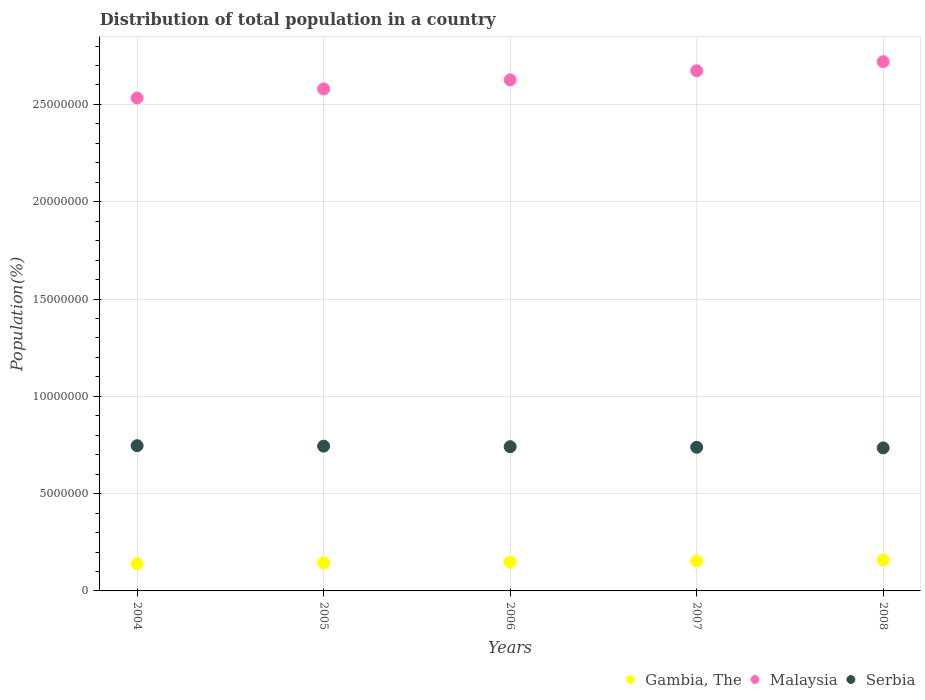Is the number of dotlines equal to the number of legend labels?
Ensure brevity in your answer.  Yes. What is the population of in Gambia, The in 2004?
Your answer should be compact. 1.39e+06. Across all years, what is the maximum population of in Malaysia?
Give a very brief answer. 2.72e+07. Across all years, what is the minimum population of in Malaysia?
Make the answer very short. 2.53e+07. In which year was the population of in Gambia, The maximum?
Your response must be concise. 2008. What is the total population of in Serbia in the graph?
Your response must be concise. 3.70e+07. What is the difference between the population of in Serbia in 2005 and that in 2008?
Offer a very short reply. 9.05e+04. What is the difference between the population of in Malaysia in 2006 and the population of in Serbia in 2007?
Make the answer very short. 1.89e+07. What is the average population of in Malaysia per year?
Keep it short and to the point. 2.63e+07. In the year 2008, what is the difference between the population of in Malaysia and population of in Serbia?
Provide a succinct answer. 1.98e+07. In how many years, is the population of in Malaysia greater than 13000000 %?
Make the answer very short. 5. What is the ratio of the population of in Malaysia in 2005 to that in 2008?
Your answer should be compact. 0.95. Is the population of in Serbia in 2005 less than that in 2006?
Keep it short and to the point. No. Is the difference between the population of in Malaysia in 2005 and 2008 greater than the difference between the population of in Serbia in 2005 and 2008?
Your response must be concise. No. What is the difference between the highest and the second highest population of in Malaysia?
Give a very brief answer. 4.67e+05. What is the difference between the highest and the lowest population of in Malaysia?
Provide a short and direct response. 1.87e+06. Is it the case that in every year, the sum of the population of in Gambia, The and population of in Serbia  is greater than the population of in Malaysia?
Give a very brief answer. No. How many years are there in the graph?
Keep it short and to the point. 5. What is the difference between two consecutive major ticks on the Y-axis?
Give a very brief answer. 5.00e+06. Are the values on the major ticks of Y-axis written in scientific E-notation?
Make the answer very short. No. Does the graph contain grids?
Your answer should be compact. Yes. How many legend labels are there?
Offer a very short reply. 3. How are the legend labels stacked?
Offer a terse response. Horizontal. What is the title of the graph?
Offer a terse response. Distribution of total population in a country. Does "Djibouti" appear as one of the legend labels in the graph?
Offer a very short reply. No. What is the label or title of the Y-axis?
Give a very brief answer. Population(%). What is the Population(%) of Gambia, The in 2004?
Your answer should be compact. 1.39e+06. What is the Population(%) in Malaysia in 2004?
Your answer should be compact. 2.53e+07. What is the Population(%) in Serbia in 2004?
Give a very brief answer. 7.46e+06. What is the Population(%) in Gambia, The in 2005?
Provide a succinct answer. 1.44e+06. What is the Population(%) of Malaysia in 2005?
Your answer should be very brief. 2.58e+07. What is the Population(%) of Serbia in 2005?
Offer a very short reply. 7.44e+06. What is the Population(%) of Gambia, The in 2006?
Provide a short and direct response. 1.49e+06. What is the Population(%) in Malaysia in 2006?
Your answer should be very brief. 2.63e+07. What is the Population(%) in Serbia in 2006?
Offer a terse response. 7.41e+06. What is the Population(%) of Gambia, The in 2007?
Offer a terse response. 1.54e+06. What is the Population(%) in Malaysia in 2007?
Offer a very short reply. 2.67e+07. What is the Population(%) in Serbia in 2007?
Make the answer very short. 7.38e+06. What is the Population(%) in Gambia, The in 2008?
Ensure brevity in your answer.  1.59e+06. What is the Population(%) of Malaysia in 2008?
Ensure brevity in your answer.  2.72e+07. What is the Population(%) of Serbia in 2008?
Offer a very short reply. 7.35e+06. Across all years, what is the maximum Population(%) in Gambia, The?
Make the answer very short. 1.59e+06. Across all years, what is the maximum Population(%) in Malaysia?
Offer a terse response. 2.72e+07. Across all years, what is the maximum Population(%) in Serbia?
Your answer should be compact. 7.46e+06. Across all years, what is the minimum Population(%) of Gambia, The?
Offer a very short reply. 1.39e+06. Across all years, what is the minimum Population(%) in Malaysia?
Offer a very short reply. 2.53e+07. Across all years, what is the minimum Population(%) of Serbia?
Provide a succinct answer. 7.35e+06. What is the total Population(%) in Gambia, The in the graph?
Your answer should be compact. 7.45e+06. What is the total Population(%) of Malaysia in the graph?
Your answer should be compact. 1.31e+08. What is the total Population(%) in Serbia in the graph?
Provide a short and direct response. 3.70e+07. What is the difference between the Population(%) of Gambia, The in 2004 and that in 2005?
Give a very brief answer. -4.58e+04. What is the difference between the Population(%) of Malaysia in 2004 and that in 2005?
Make the answer very short. -4.64e+05. What is the difference between the Population(%) in Serbia in 2004 and that in 2005?
Your response must be concise. 2.24e+04. What is the difference between the Population(%) in Gambia, The in 2004 and that in 2006?
Make the answer very short. -9.30e+04. What is the difference between the Population(%) of Malaysia in 2004 and that in 2006?
Offer a terse response. -9.31e+05. What is the difference between the Population(%) of Serbia in 2004 and that in 2006?
Give a very brief answer. 5.16e+04. What is the difference between the Population(%) of Gambia, The in 2004 and that in 2007?
Your answer should be compact. -1.42e+05. What is the difference between the Population(%) of Malaysia in 2004 and that in 2007?
Make the answer very short. -1.40e+06. What is the difference between the Population(%) of Serbia in 2004 and that in 2007?
Your response must be concise. 8.16e+04. What is the difference between the Population(%) in Gambia, The in 2004 and that in 2008?
Offer a very short reply. -1.92e+05. What is the difference between the Population(%) of Malaysia in 2004 and that in 2008?
Your answer should be compact. -1.87e+06. What is the difference between the Population(%) of Serbia in 2004 and that in 2008?
Your answer should be very brief. 1.13e+05. What is the difference between the Population(%) of Gambia, The in 2005 and that in 2006?
Ensure brevity in your answer.  -4.72e+04. What is the difference between the Population(%) in Malaysia in 2005 and that in 2006?
Offer a very short reply. -4.67e+05. What is the difference between the Population(%) in Serbia in 2005 and that in 2006?
Offer a terse response. 2.92e+04. What is the difference between the Population(%) of Gambia, The in 2005 and that in 2007?
Offer a very short reply. -9.59e+04. What is the difference between the Population(%) of Malaysia in 2005 and that in 2007?
Keep it short and to the point. -9.34e+05. What is the difference between the Population(%) in Serbia in 2005 and that in 2007?
Give a very brief answer. 5.92e+04. What is the difference between the Population(%) of Gambia, The in 2005 and that in 2008?
Offer a very short reply. -1.46e+05. What is the difference between the Population(%) of Malaysia in 2005 and that in 2008?
Provide a short and direct response. -1.40e+06. What is the difference between the Population(%) of Serbia in 2005 and that in 2008?
Your response must be concise. 9.05e+04. What is the difference between the Population(%) in Gambia, The in 2006 and that in 2007?
Your response must be concise. -4.87e+04. What is the difference between the Population(%) in Malaysia in 2006 and that in 2007?
Provide a succinct answer. -4.68e+05. What is the difference between the Population(%) in Serbia in 2006 and that in 2007?
Offer a very short reply. 3.00e+04. What is the difference between the Population(%) in Gambia, The in 2006 and that in 2008?
Offer a terse response. -9.90e+04. What is the difference between the Population(%) in Malaysia in 2006 and that in 2008?
Provide a short and direct response. -9.34e+05. What is the difference between the Population(%) in Serbia in 2006 and that in 2008?
Keep it short and to the point. 6.13e+04. What is the difference between the Population(%) in Gambia, The in 2007 and that in 2008?
Provide a short and direct response. -5.03e+04. What is the difference between the Population(%) of Malaysia in 2007 and that in 2008?
Make the answer very short. -4.67e+05. What is the difference between the Population(%) in Serbia in 2007 and that in 2008?
Keep it short and to the point. 3.14e+04. What is the difference between the Population(%) of Gambia, The in 2004 and the Population(%) of Malaysia in 2005?
Your response must be concise. -2.44e+07. What is the difference between the Population(%) of Gambia, The in 2004 and the Population(%) of Serbia in 2005?
Provide a short and direct response. -6.05e+06. What is the difference between the Population(%) in Malaysia in 2004 and the Population(%) in Serbia in 2005?
Your answer should be very brief. 1.79e+07. What is the difference between the Population(%) in Gambia, The in 2004 and the Population(%) in Malaysia in 2006?
Keep it short and to the point. -2.49e+07. What is the difference between the Population(%) in Gambia, The in 2004 and the Population(%) in Serbia in 2006?
Ensure brevity in your answer.  -6.02e+06. What is the difference between the Population(%) of Malaysia in 2004 and the Population(%) of Serbia in 2006?
Your answer should be very brief. 1.79e+07. What is the difference between the Population(%) of Gambia, The in 2004 and the Population(%) of Malaysia in 2007?
Keep it short and to the point. -2.53e+07. What is the difference between the Population(%) of Gambia, The in 2004 and the Population(%) of Serbia in 2007?
Offer a terse response. -5.99e+06. What is the difference between the Population(%) of Malaysia in 2004 and the Population(%) of Serbia in 2007?
Provide a succinct answer. 1.80e+07. What is the difference between the Population(%) of Gambia, The in 2004 and the Population(%) of Malaysia in 2008?
Provide a short and direct response. -2.58e+07. What is the difference between the Population(%) of Gambia, The in 2004 and the Population(%) of Serbia in 2008?
Ensure brevity in your answer.  -5.96e+06. What is the difference between the Population(%) in Malaysia in 2004 and the Population(%) in Serbia in 2008?
Your answer should be very brief. 1.80e+07. What is the difference between the Population(%) of Gambia, The in 2005 and the Population(%) of Malaysia in 2006?
Your answer should be very brief. -2.48e+07. What is the difference between the Population(%) of Gambia, The in 2005 and the Population(%) of Serbia in 2006?
Provide a succinct answer. -5.97e+06. What is the difference between the Population(%) in Malaysia in 2005 and the Population(%) in Serbia in 2006?
Provide a short and direct response. 1.84e+07. What is the difference between the Population(%) in Gambia, The in 2005 and the Population(%) in Malaysia in 2007?
Your response must be concise. -2.53e+07. What is the difference between the Population(%) in Gambia, The in 2005 and the Population(%) in Serbia in 2007?
Keep it short and to the point. -5.94e+06. What is the difference between the Population(%) in Malaysia in 2005 and the Population(%) in Serbia in 2007?
Give a very brief answer. 1.84e+07. What is the difference between the Population(%) of Gambia, The in 2005 and the Population(%) of Malaysia in 2008?
Your answer should be very brief. -2.58e+07. What is the difference between the Population(%) of Gambia, The in 2005 and the Population(%) of Serbia in 2008?
Provide a succinct answer. -5.91e+06. What is the difference between the Population(%) in Malaysia in 2005 and the Population(%) in Serbia in 2008?
Make the answer very short. 1.84e+07. What is the difference between the Population(%) in Gambia, The in 2006 and the Population(%) in Malaysia in 2007?
Provide a succinct answer. -2.52e+07. What is the difference between the Population(%) of Gambia, The in 2006 and the Population(%) of Serbia in 2007?
Your answer should be compact. -5.89e+06. What is the difference between the Population(%) in Malaysia in 2006 and the Population(%) in Serbia in 2007?
Give a very brief answer. 1.89e+07. What is the difference between the Population(%) in Gambia, The in 2006 and the Population(%) in Malaysia in 2008?
Offer a very short reply. -2.57e+07. What is the difference between the Population(%) of Gambia, The in 2006 and the Population(%) of Serbia in 2008?
Provide a succinct answer. -5.86e+06. What is the difference between the Population(%) in Malaysia in 2006 and the Population(%) in Serbia in 2008?
Offer a terse response. 1.89e+07. What is the difference between the Population(%) of Gambia, The in 2007 and the Population(%) of Malaysia in 2008?
Ensure brevity in your answer.  -2.57e+07. What is the difference between the Population(%) in Gambia, The in 2007 and the Population(%) in Serbia in 2008?
Your response must be concise. -5.81e+06. What is the difference between the Population(%) of Malaysia in 2007 and the Population(%) of Serbia in 2008?
Keep it short and to the point. 1.94e+07. What is the average Population(%) of Gambia, The per year?
Your response must be concise. 1.49e+06. What is the average Population(%) in Malaysia per year?
Ensure brevity in your answer.  2.63e+07. What is the average Population(%) in Serbia per year?
Provide a short and direct response. 7.41e+06. In the year 2004, what is the difference between the Population(%) in Gambia, The and Population(%) in Malaysia?
Give a very brief answer. -2.39e+07. In the year 2004, what is the difference between the Population(%) of Gambia, The and Population(%) of Serbia?
Provide a short and direct response. -6.07e+06. In the year 2004, what is the difference between the Population(%) of Malaysia and Population(%) of Serbia?
Give a very brief answer. 1.79e+07. In the year 2005, what is the difference between the Population(%) in Gambia, The and Population(%) in Malaysia?
Your answer should be very brief. -2.44e+07. In the year 2005, what is the difference between the Population(%) in Gambia, The and Population(%) in Serbia?
Your response must be concise. -6.00e+06. In the year 2005, what is the difference between the Population(%) in Malaysia and Population(%) in Serbia?
Provide a succinct answer. 1.84e+07. In the year 2006, what is the difference between the Population(%) in Gambia, The and Population(%) in Malaysia?
Ensure brevity in your answer.  -2.48e+07. In the year 2006, what is the difference between the Population(%) of Gambia, The and Population(%) of Serbia?
Provide a succinct answer. -5.92e+06. In the year 2006, what is the difference between the Population(%) of Malaysia and Population(%) of Serbia?
Your answer should be very brief. 1.89e+07. In the year 2007, what is the difference between the Population(%) of Gambia, The and Population(%) of Malaysia?
Your answer should be compact. -2.52e+07. In the year 2007, what is the difference between the Population(%) in Gambia, The and Population(%) in Serbia?
Provide a short and direct response. -5.85e+06. In the year 2007, what is the difference between the Population(%) of Malaysia and Population(%) of Serbia?
Your answer should be very brief. 1.93e+07. In the year 2008, what is the difference between the Population(%) of Gambia, The and Population(%) of Malaysia?
Keep it short and to the point. -2.56e+07. In the year 2008, what is the difference between the Population(%) of Gambia, The and Population(%) of Serbia?
Provide a succinct answer. -5.76e+06. In the year 2008, what is the difference between the Population(%) of Malaysia and Population(%) of Serbia?
Offer a very short reply. 1.98e+07. What is the ratio of the Population(%) of Gambia, The in 2004 to that in 2005?
Offer a terse response. 0.97. What is the ratio of the Population(%) of Gambia, The in 2004 to that in 2006?
Offer a terse response. 0.94. What is the ratio of the Population(%) in Malaysia in 2004 to that in 2006?
Offer a terse response. 0.96. What is the ratio of the Population(%) of Serbia in 2004 to that in 2006?
Give a very brief answer. 1.01. What is the ratio of the Population(%) in Gambia, The in 2004 to that in 2007?
Your answer should be compact. 0.91. What is the ratio of the Population(%) in Malaysia in 2004 to that in 2007?
Your answer should be very brief. 0.95. What is the ratio of the Population(%) in Serbia in 2004 to that in 2007?
Ensure brevity in your answer.  1.01. What is the ratio of the Population(%) in Gambia, The in 2004 to that in 2008?
Ensure brevity in your answer.  0.88. What is the ratio of the Population(%) in Malaysia in 2004 to that in 2008?
Keep it short and to the point. 0.93. What is the ratio of the Population(%) in Serbia in 2004 to that in 2008?
Keep it short and to the point. 1.02. What is the ratio of the Population(%) of Gambia, The in 2005 to that in 2006?
Your answer should be compact. 0.97. What is the ratio of the Population(%) in Malaysia in 2005 to that in 2006?
Provide a short and direct response. 0.98. What is the ratio of the Population(%) in Serbia in 2005 to that in 2006?
Offer a terse response. 1. What is the ratio of the Population(%) in Gambia, The in 2005 to that in 2007?
Make the answer very short. 0.94. What is the ratio of the Population(%) of Serbia in 2005 to that in 2007?
Your response must be concise. 1.01. What is the ratio of the Population(%) in Gambia, The in 2005 to that in 2008?
Your response must be concise. 0.91. What is the ratio of the Population(%) of Malaysia in 2005 to that in 2008?
Your response must be concise. 0.95. What is the ratio of the Population(%) in Serbia in 2005 to that in 2008?
Your response must be concise. 1.01. What is the ratio of the Population(%) of Gambia, The in 2006 to that in 2007?
Keep it short and to the point. 0.97. What is the ratio of the Population(%) in Malaysia in 2006 to that in 2007?
Offer a very short reply. 0.98. What is the ratio of the Population(%) in Serbia in 2006 to that in 2007?
Your response must be concise. 1. What is the ratio of the Population(%) in Gambia, The in 2006 to that in 2008?
Keep it short and to the point. 0.94. What is the ratio of the Population(%) in Malaysia in 2006 to that in 2008?
Offer a very short reply. 0.97. What is the ratio of the Population(%) in Serbia in 2006 to that in 2008?
Your answer should be very brief. 1.01. What is the ratio of the Population(%) of Gambia, The in 2007 to that in 2008?
Ensure brevity in your answer.  0.97. What is the ratio of the Population(%) in Malaysia in 2007 to that in 2008?
Give a very brief answer. 0.98. What is the difference between the highest and the second highest Population(%) in Gambia, The?
Your response must be concise. 5.03e+04. What is the difference between the highest and the second highest Population(%) in Malaysia?
Provide a short and direct response. 4.67e+05. What is the difference between the highest and the second highest Population(%) in Serbia?
Provide a succinct answer. 2.24e+04. What is the difference between the highest and the lowest Population(%) of Gambia, The?
Ensure brevity in your answer.  1.92e+05. What is the difference between the highest and the lowest Population(%) of Malaysia?
Give a very brief answer. 1.87e+06. What is the difference between the highest and the lowest Population(%) in Serbia?
Keep it short and to the point. 1.13e+05. 